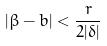<formula> <loc_0><loc_0><loc_500><loc_500>| \beta - b | < \frac { r } { 2 | \delta | }</formula> 